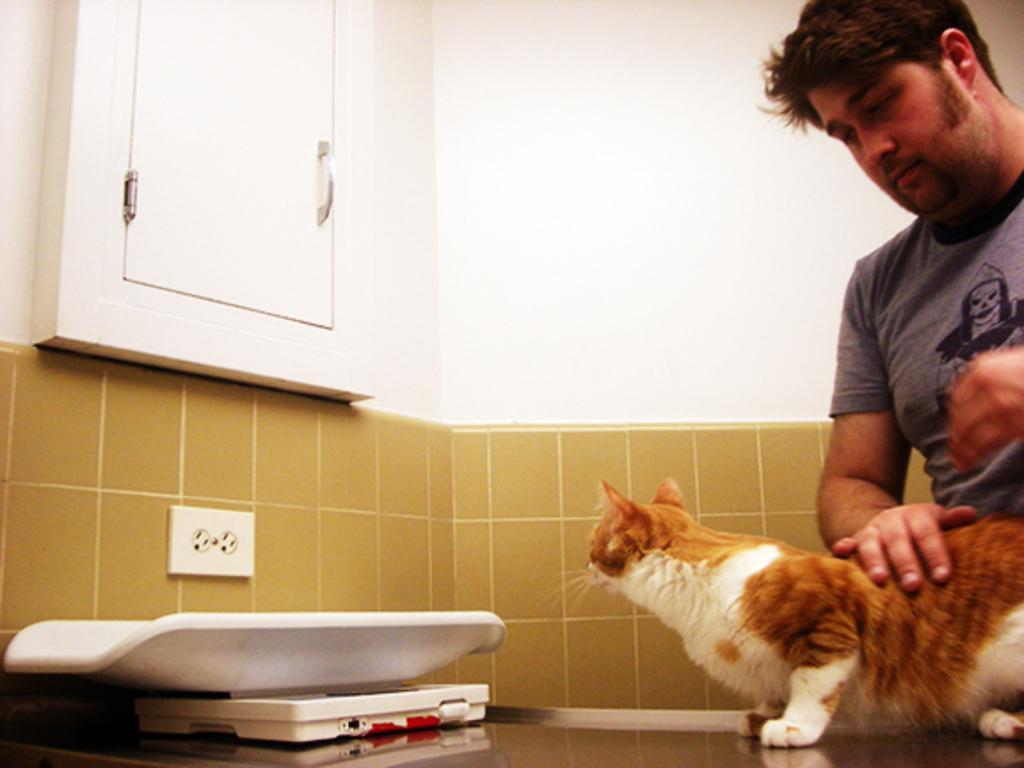What animal is on the desk in the image? There is a cat on the desk in the image. What is the man in the image doing with the cat? The man has his hand on the cat. What can be seen in the background of the image? There is a cupboard door and a wall visible in the background of the image. Where is the playground located in the image? There is no playground present in the image. What type of lead is the cat using to communicate with the man? The cat is not using any lead to communicate with the man; it is a living animal and not a device. 